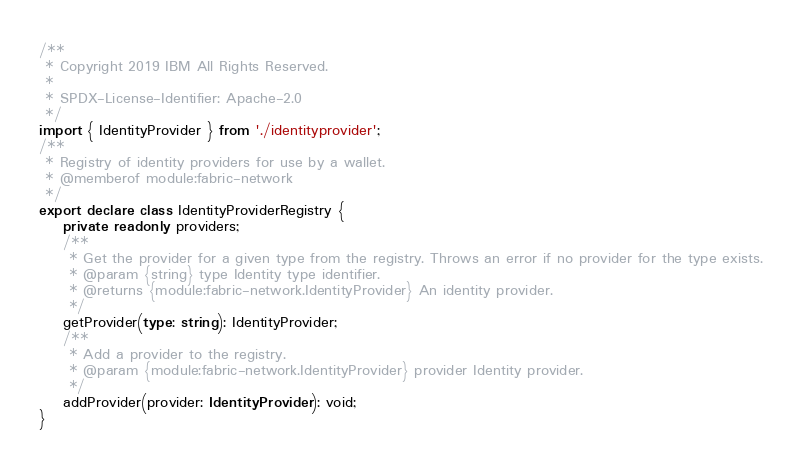Convert code to text. <code><loc_0><loc_0><loc_500><loc_500><_TypeScript_>/**
 * Copyright 2019 IBM All Rights Reserved.
 *
 * SPDX-License-Identifier: Apache-2.0
 */
import { IdentityProvider } from './identityprovider';
/**
 * Registry of identity providers for use by a wallet.
 * @memberof module:fabric-network
 */
export declare class IdentityProviderRegistry {
    private readonly providers;
    /**
     * Get the provider for a given type from the registry. Throws an error if no provider for the type exists.
     * @param {string} type Identity type identifier.
     * @returns {module:fabric-network.IdentityProvider} An identity provider.
     */
    getProvider(type: string): IdentityProvider;
    /**
     * Add a provider to the registry.
     * @param {module:fabric-network.IdentityProvider} provider Identity provider.
     */
    addProvider(provider: IdentityProvider): void;
}
</code> 